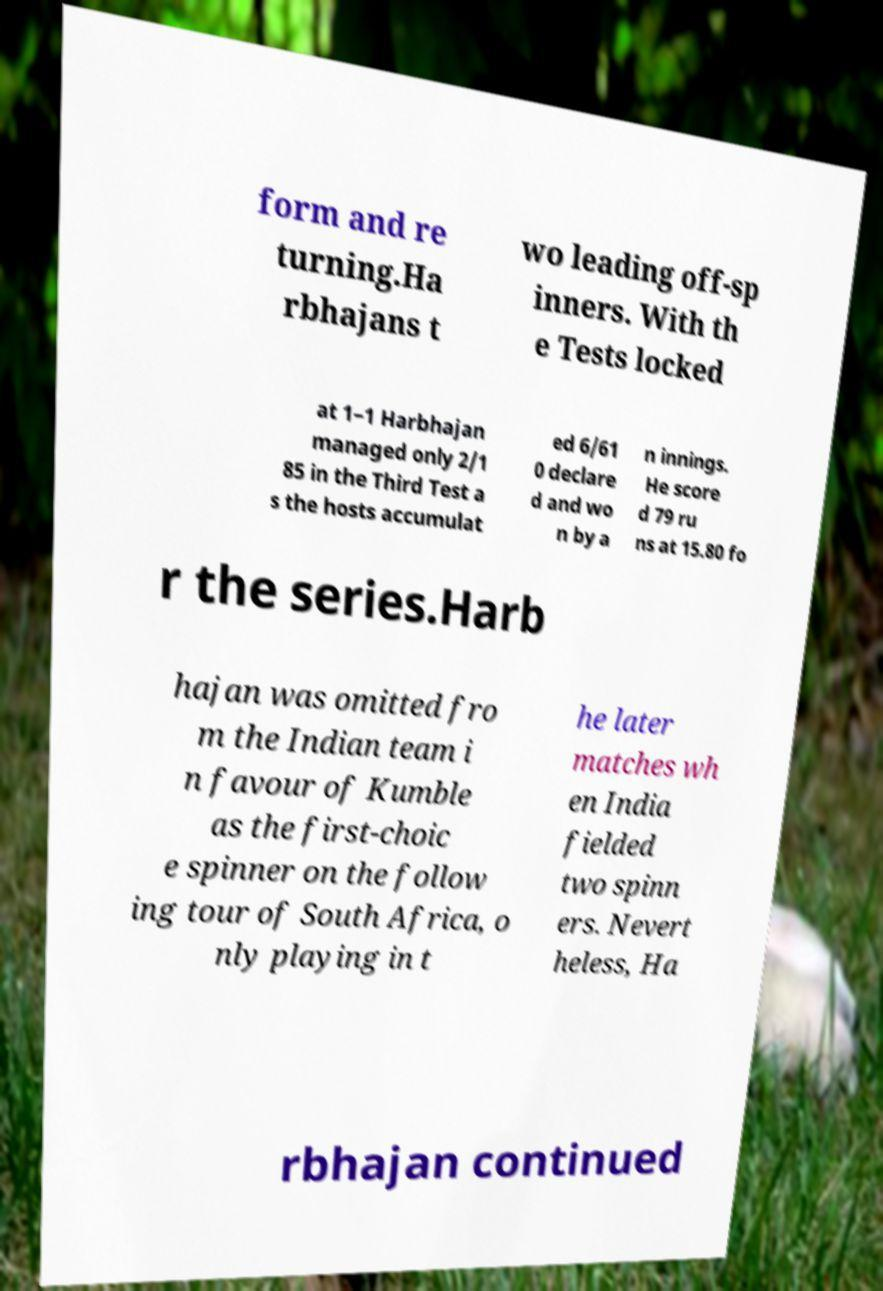Can you accurately transcribe the text from the provided image for me? form and re turning.Ha rbhajans t wo leading off-sp inners. With th e Tests locked at 1–1 Harbhajan managed only 2/1 85 in the Third Test a s the hosts accumulat ed 6/61 0 declare d and wo n by a n innings. He score d 79 ru ns at 15.80 fo r the series.Harb hajan was omitted fro m the Indian team i n favour of Kumble as the first-choic e spinner on the follow ing tour of South Africa, o nly playing in t he later matches wh en India fielded two spinn ers. Nevert heless, Ha rbhajan continued 